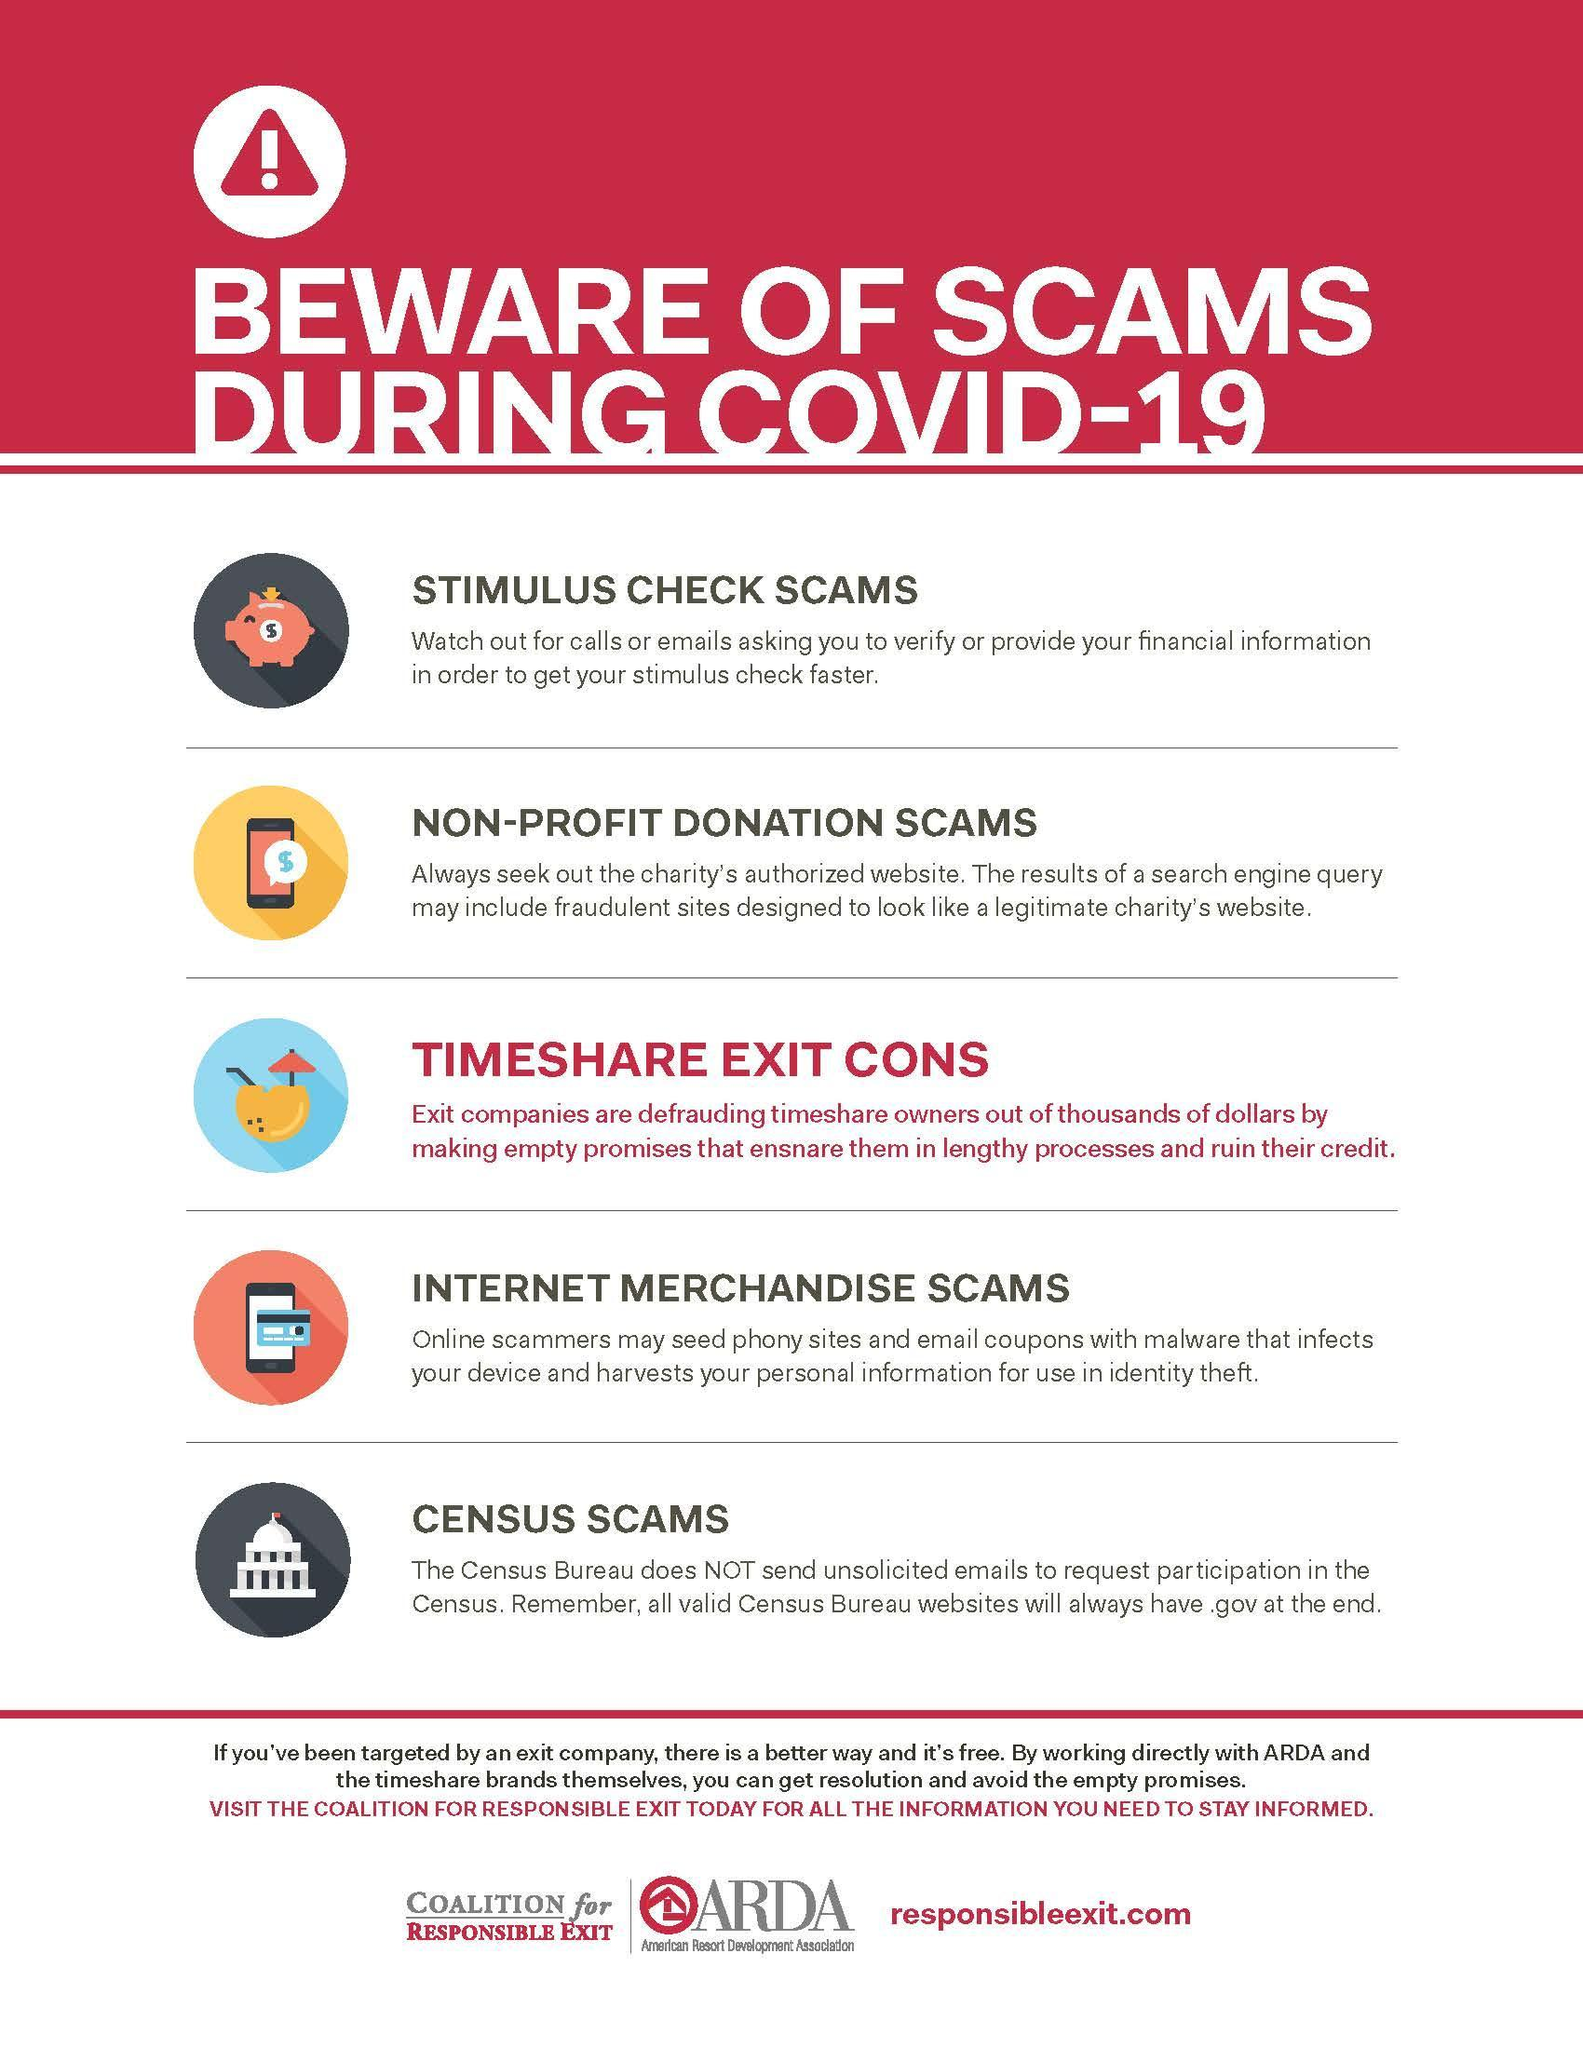WHat type of scam is indicated by the electronic card and smart phone
Answer the question with a short phrase. Internet merchandise scams How many types of scams have been highlighted 5 WHat type of scam is indicated by the piggy bank Stimulus check scams 